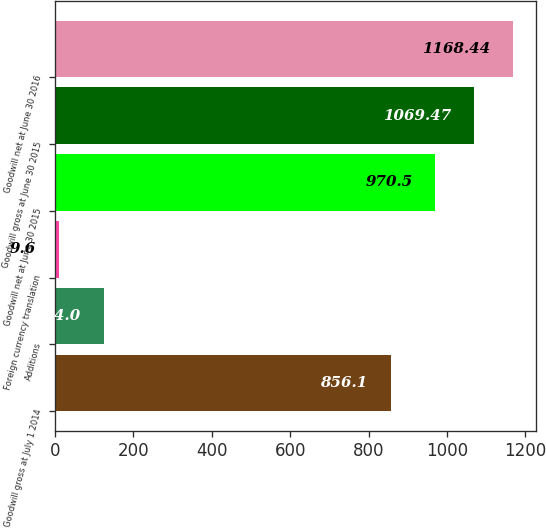Convert chart. <chart><loc_0><loc_0><loc_500><loc_500><bar_chart><fcel>Goodwill gross at July 1 2014<fcel>Additions<fcel>Foreign currency translation<fcel>Goodwill net at June 30 2015<fcel>Goodwill gross at June 30 2015<fcel>Goodwill net at June 30 2016<nl><fcel>856.1<fcel>124<fcel>9.6<fcel>970.5<fcel>1069.47<fcel>1168.44<nl></chart> 